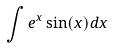<formula> <loc_0><loc_0><loc_500><loc_500>\int e ^ { x } \sin ( x ) d x</formula> 